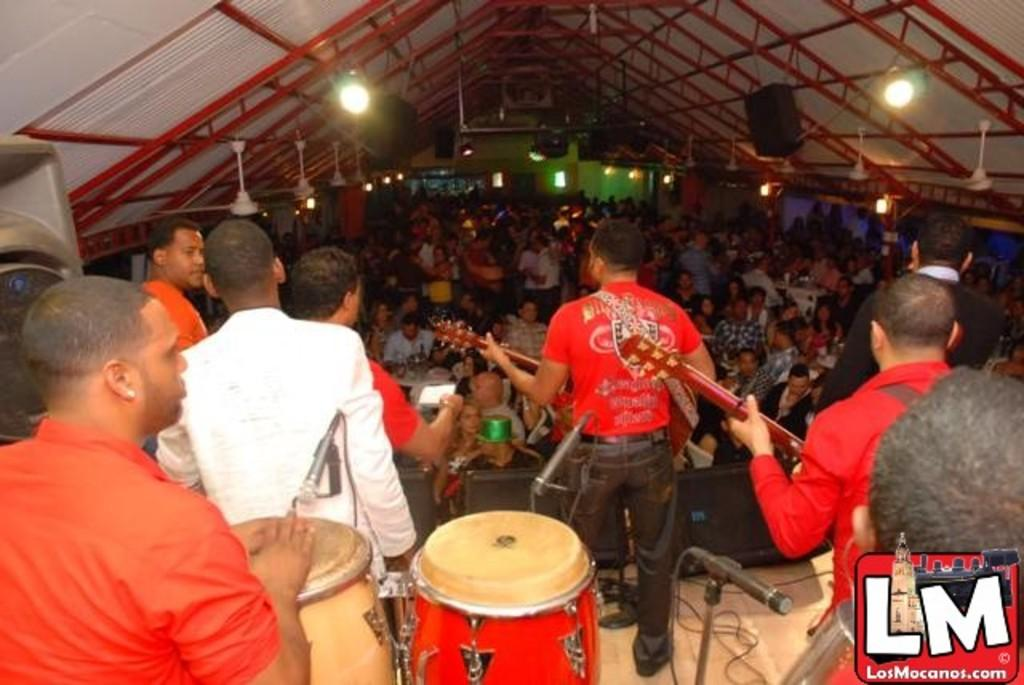What is happening in the image involving a group of people? In the image, a group of people are playing musical instruments. Who is present in the image besides the group of people playing musical instruments? There is an audience present in the image. What type of operation is being performed on the musical instruments in the image? There is no operation being performed on the musical instruments in the image; they are being played by the group of people. 